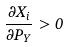<formula> <loc_0><loc_0><loc_500><loc_500>\frac { \partial X _ { i } } { \partial P _ { Y } } > 0</formula> 